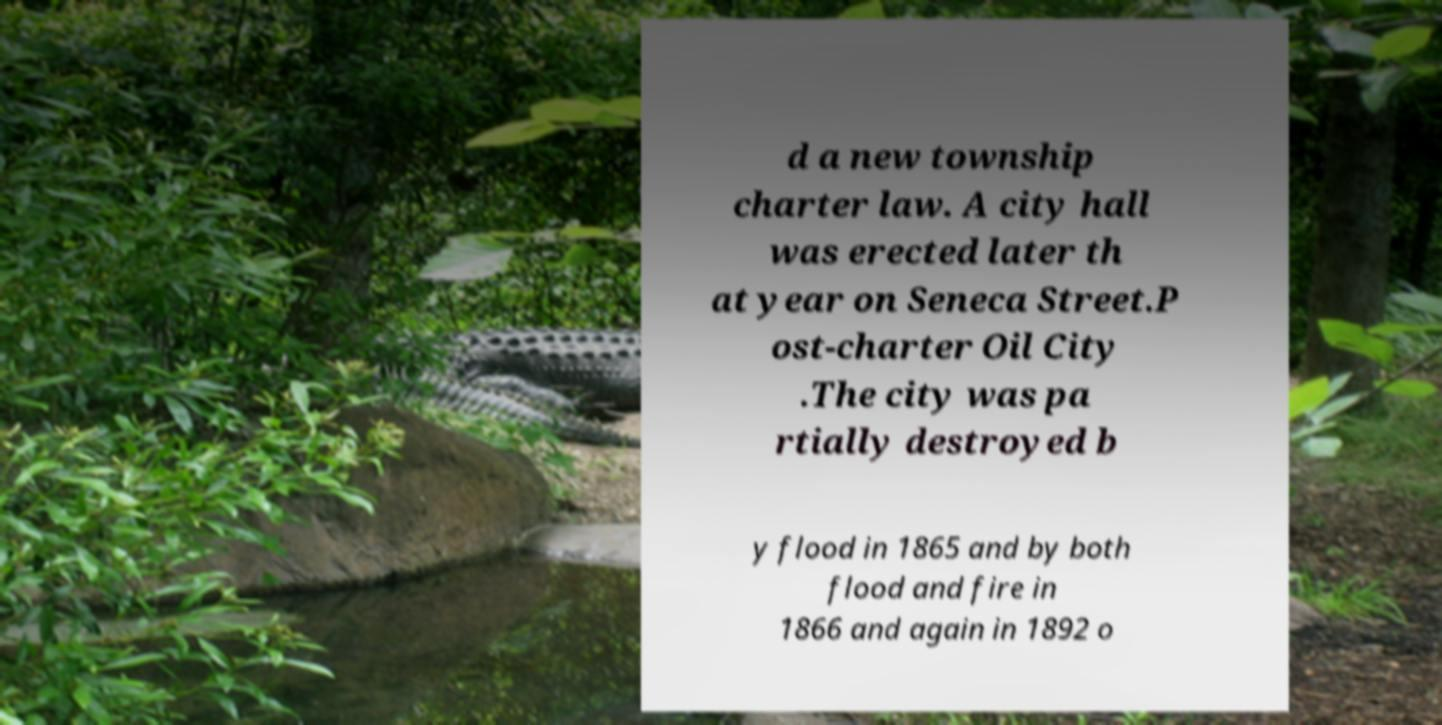There's text embedded in this image that I need extracted. Can you transcribe it verbatim? d a new township charter law. A city hall was erected later th at year on Seneca Street.P ost-charter Oil City .The city was pa rtially destroyed b y flood in 1865 and by both flood and fire in 1866 and again in 1892 o 